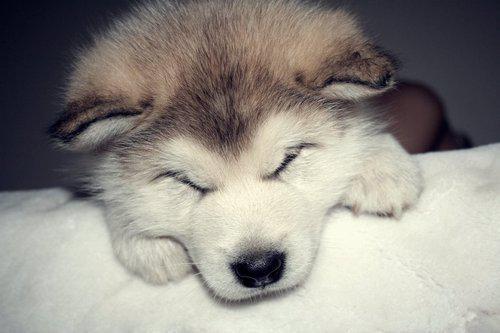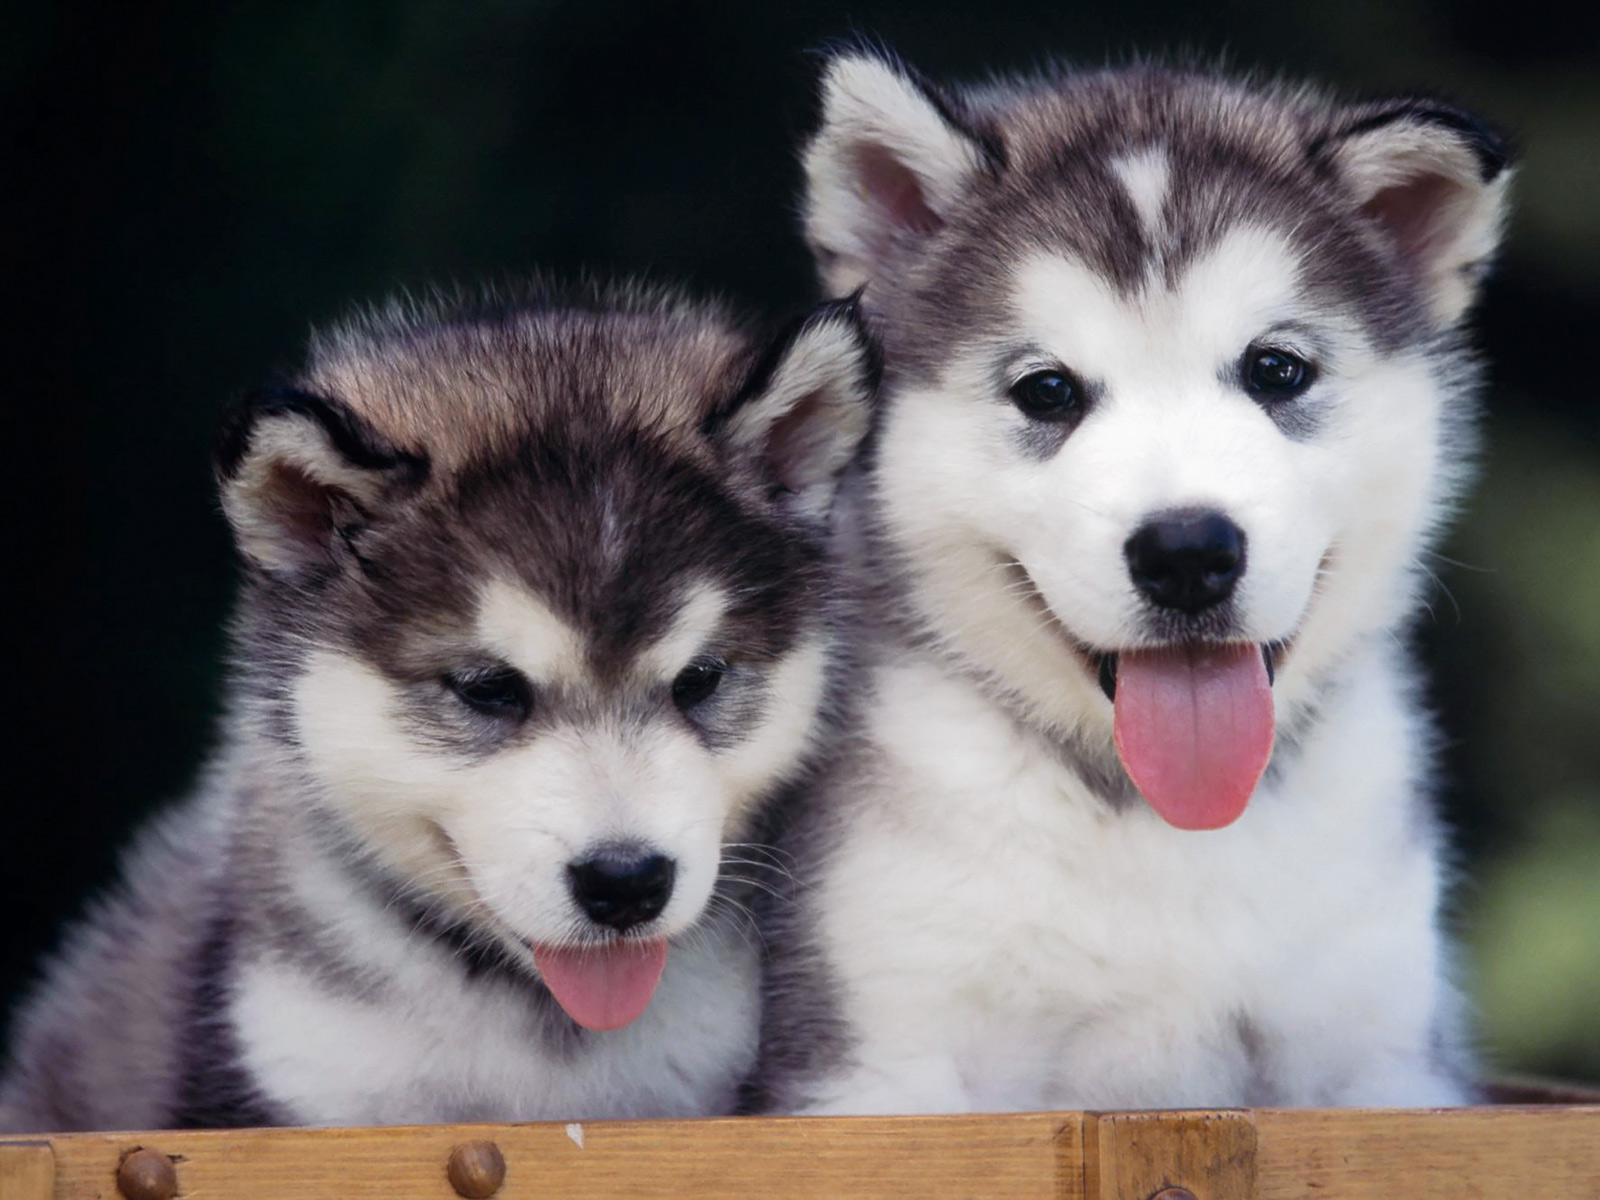The first image is the image on the left, the second image is the image on the right. Analyze the images presented: Is the assertion "The right image features two side-by-side forward-facing puppies with closed mouths." valid? Answer yes or no. No. The first image is the image on the left, the second image is the image on the right. Examine the images to the left and right. Is the description "There is one puppy with black fur, and the other dogs have brown fur." accurate? Answer yes or no. No. 